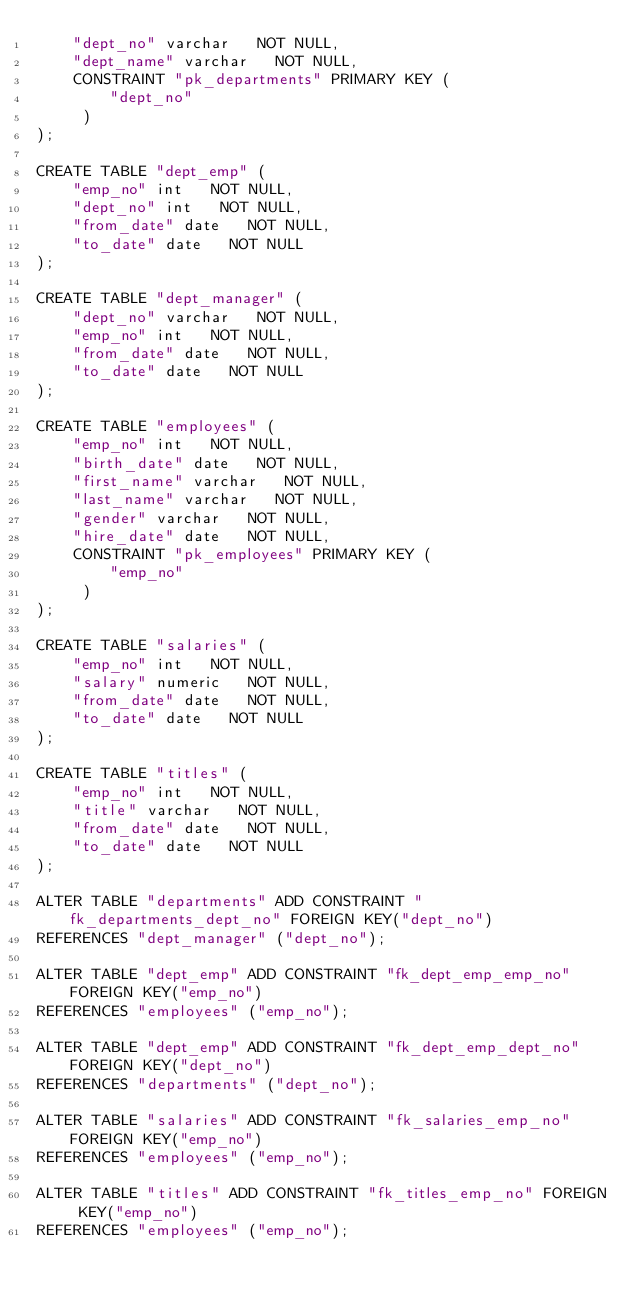Convert code to text. <code><loc_0><loc_0><loc_500><loc_500><_SQL_>    "dept_no" varchar   NOT NULL,
    "dept_name" varchar   NOT NULL,
    CONSTRAINT "pk_departments" PRIMARY KEY (
        "dept_no"
     )
);

CREATE TABLE "dept_emp" (
    "emp_no" int   NOT NULL,
    "dept_no" int   NOT NULL,
    "from_date" date   NOT NULL,
    "to_date" date   NOT NULL
);

CREATE TABLE "dept_manager" (
    "dept_no" varchar   NOT NULL,
    "emp_no" int   NOT NULL,
    "from_date" date   NOT NULL,
    "to_date" date   NOT NULL
);

CREATE TABLE "employees" (
    "emp_no" int   NOT NULL,
    "birth_date" date   NOT NULL,
    "first_name" varchar   NOT NULL,
    "last_name" varchar   NOT NULL,
    "gender" varchar   NOT NULL,
    "hire_date" date   NOT NULL,
    CONSTRAINT "pk_employees" PRIMARY KEY (
        "emp_no"
     )
);

CREATE TABLE "salaries" (
    "emp_no" int   NOT NULL,
    "salary" numeric   NOT NULL,
    "from_date" date   NOT NULL,
    "to_date" date   NOT NULL
);

CREATE TABLE "titles" (
    "emp_no" int   NOT NULL,
    "title" varchar   NOT NULL,
    "from_date" date   NOT NULL,
    "to_date" date   NOT NULL
);

ALTER TABLE "departments" ADD CONSTRAINT "fk_departments_dept_no" FOREIGN KEY("dept_no")
REFERENCES "dept_manager" ("dept_no");

ALTER TABLE "dept_emp" ADD CONSTRAINT "fk_dept_emp_emp_no" FOREIGN KEY("emp_no")
REFERENCES "employees" ("emp_no");

ALTER TABLE "dept_emp" ADD CONSTRAINT "fk_dept_emp_dept_no" FOREIGN KEY("dept_no")
REFERENCES "departments" ("dept_no");

ALTER TABLE "salaries" ADD CONSTRAINT "fk_salaries_emp_no" FOREIGN KEY("emp_no")
REFERENCES "employees" ("emp_no");

ALTER TABLE "titles" ADD CONSTRAINT "fk_titles_emp_no" FOREIGN KEY("emp_no")
REFERENCES "employees" ("emp_no");

</code> 